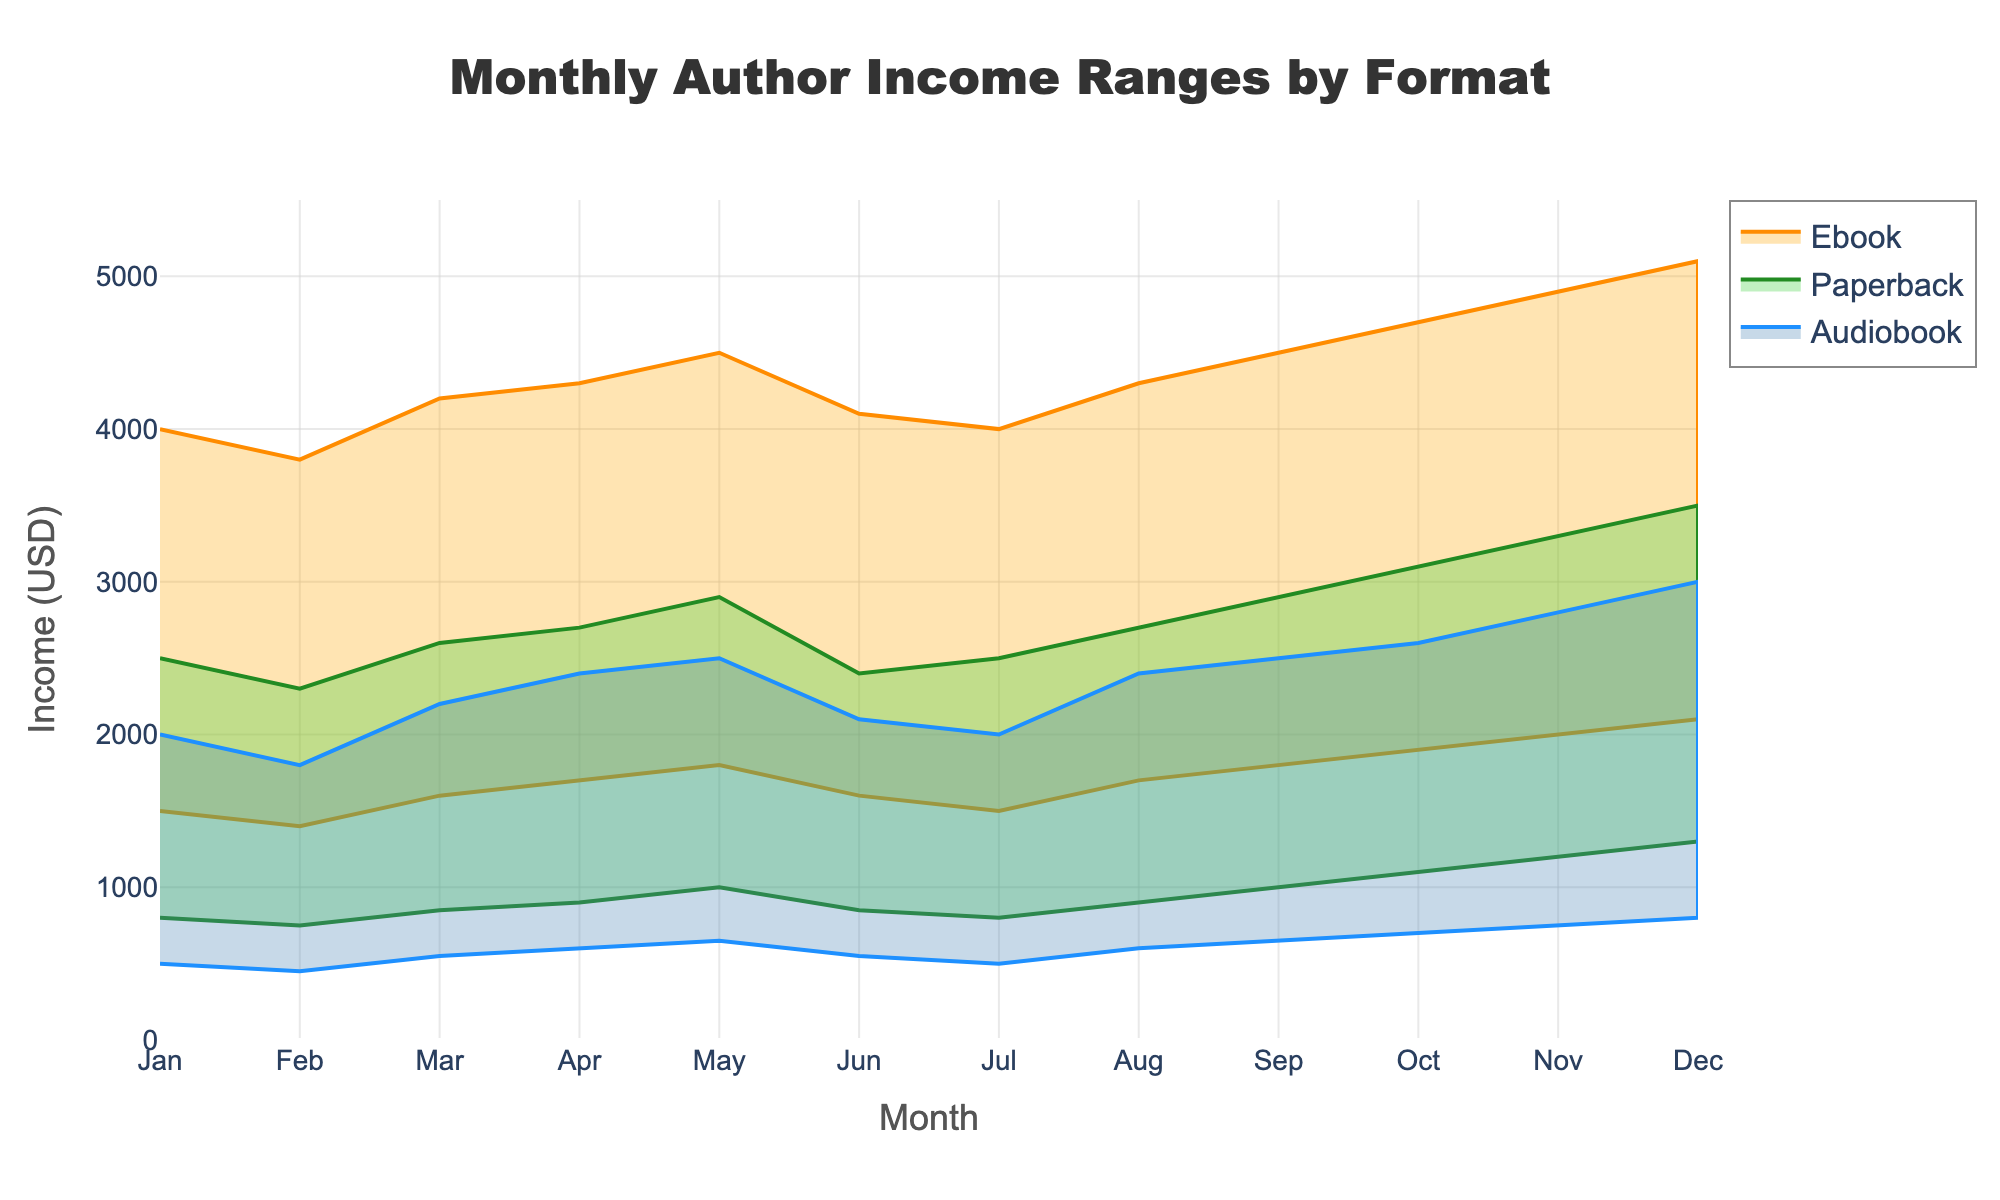What is the title of the chart? The title of the chart is located at the top and reads "Monthly Author Income Ranges by Format".
Answer: Monthly Author Income Ranges by Format Which format has the highest income range in December? By observing the data points in December, the maximum for each format is: Ebook - 5100, Paperback - 3500, Audiobook - 3000. Therefore, the highest income range is for Ebooks.
Answer: Ebooks Which month has the highest upper income limit for Paperbacks? The highest value for the Paperback high income range can be found on the y-axis corresponding to each month. October and November have 3300 and 3500 respectively, so December has the highest upper limit.
Answer: December What is the income range for Audiobooks in July? Refer to the plot's shaded areas or data points for Audiobooks in July: the low value is 500 and the high value is 2000. Therefore, the range is 2000 - 500.
Answer: 1500 Which format has the narrowest income range in February? For February, the differences between high and low values of each format are calculated: Ebook (3800-1400=2400), Paperback (2300-750=1550), Audiobook (1800-450=1350). Audiobooks have the smallest range.
Answer: Audiobooks Between which two consecutive months does the income range of Ebooks increase the most? Track the Ebook income range month over month. Compare the range differences between each month pair. The largest incremental change occurs between April (2600) and May (2700), so the increase is 100 units.
Answer: April to May In which months do the income ranges for all formats overlap? Overlap occurs where all shaded areas intersect, for this consider overlapping ranges. Monthly ranges must all intersect; in July: Ebook (1500-4000), Paperback (800-2500), Audiobook (500-2000); they all have ranges between 1500 and 2000.
Answer: July What's the average upper limit for Audiobooks throughout the year? Sum the upper bounds for Audiobooks (2000 + 1800 + 2200 + 2400 + 2500 + 2100 + 2000 + 2400 + 2500 + 2600 + 2800 + 3000) and divide by 12 months. The total is 28300, so 28300/12 = 2358.33.
Answer: 2358.33 Is the income range trend for Paperbacks increasing or decreasing throughout the year? Formally examine the trend for both upper and lower limits per month. Inspect the trend line for Paperbacks, which shows an increase from low of 800 to 1300 and high of 2500 to 3500. Therefore, it is increasing.
Answer: Increasing 